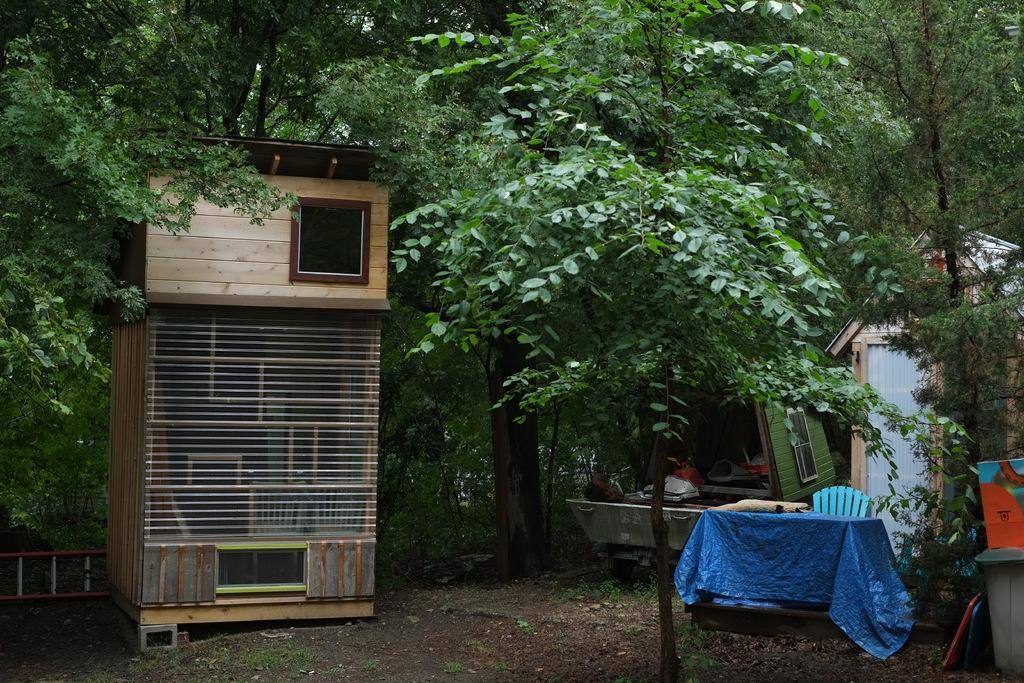Can you describe this image briefly? In this image there are trees truncated towards the top of the image, there are objects on the ground, there is a chair, there is a house truncated towards the right of the image, there are objects truncated towards the right of the image. 